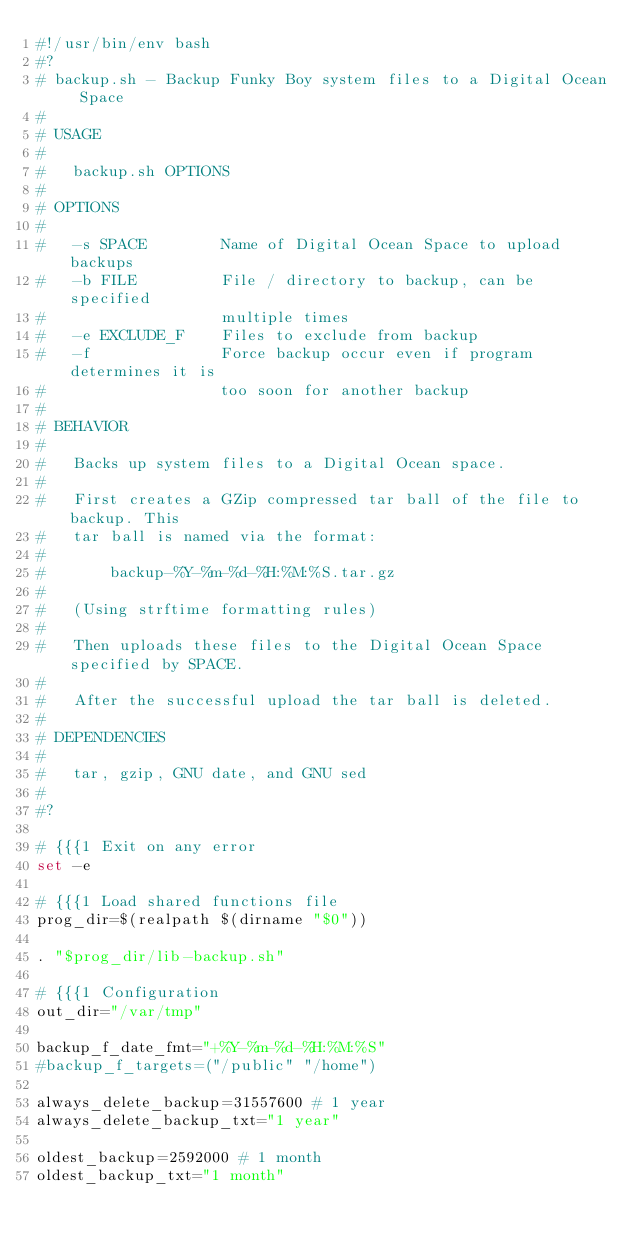Convert code to text. <code><loc_0><loc_0><loc_500><loc_500><_Bash_>#!/usr/bin/env bash
#?
# backup.sh - Backup Funky Boy system files to a Digital Ocean Space
# 
# USAGE
#
#	backup.sh OPTIONS
#
# OPTIONS
#
#	-s SPACE        Name of Digital Ocean Space to upload backups
#	-b FILE         File / directory to backup, can be specified 
#	                multiple times
#	-e EXCLUDE_F    Files to exclude from backup
#	-f              Force backup occur even if program determines it is
#	                too soon for another backup
#
# BEHAVIOR
#
#	Backs up system files to a Digital Ocean space. 
#
#	First creates a GZip compressed tar ball of the file to backup. This 
#	tar ball is named via the format:
#
#		backup-%Y-%m-%d-%H:%M:%S.tar.gz
#	
#	(Using strftime formatting rules)
#
#	Then uploads these files to the Digital Ocean Space specified by SPACE.
#
# 	After the successful upload the tar ball is deleted.
#
# DEPENDENCIES
#
#	tar, gzip, GNU date, and GNU sed
#
#?

# {{{1 Exit on any error
set -e

# {{{1 Load shared functions file
prog_dir=$(realpath $(dirname "$0"))

. "$prog_dir/lib-backup.sh"

# {{{1 Configuration
out_dir="/var/tmp"

backup_f_date_fmt="+%Y-%m-%d-%H:%M:%S"
#backup_f_targets=("/public" "/home")

always_delete_backup=31557600 # 1 year
always_delete_backup_txt="1 year"

oldest_backup=2592000 # 1 month
oldest_backup_txt="1 month"
</code> 